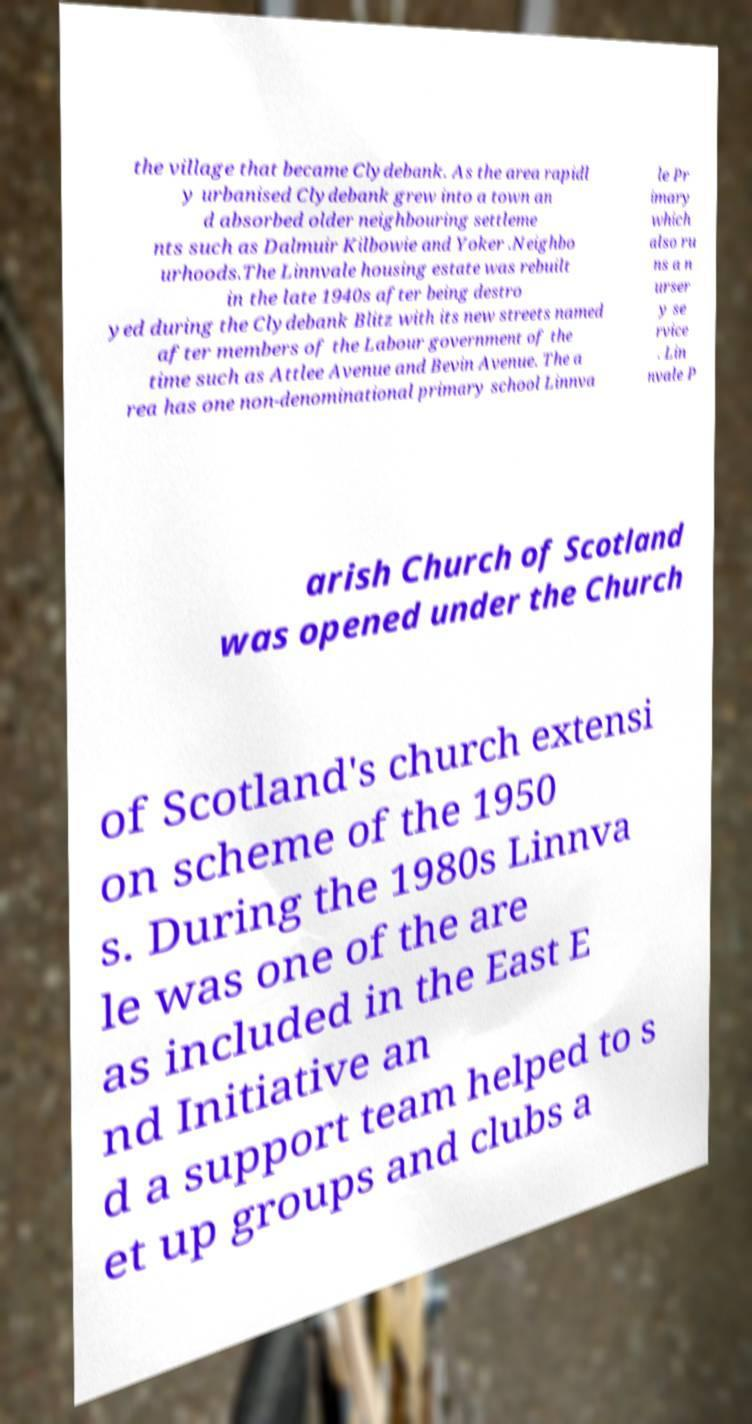I need the written content from this picture converted into text. Can you do that? the village that became Clydebank. As the area rapidl y urbanised Clydebank grew into a town an d absorbed older neighbouring settleme nts such as Dalmuir Kilbowie and Yoker .Neighbo urhoods.The Linnvale housing estate was rebuilt in the late 1940s after being destro yed during the Clydebank Blitz with its new streets named after members of the Labour government of the time such as Attlee Avenue and Bevin Avenue. The a rea has one non-denominational primary school Linnva le Pr imary which also ru ns a n urser y se rvice . Lin nvale P arish Church of Scotland was opened under the Church of Scotland's church extensi on scheme of the 1950 s. During the 1980s Linnva le was one of the are as included in the East E nd Initiative an d a support team helped to s et up groups and clubs a 